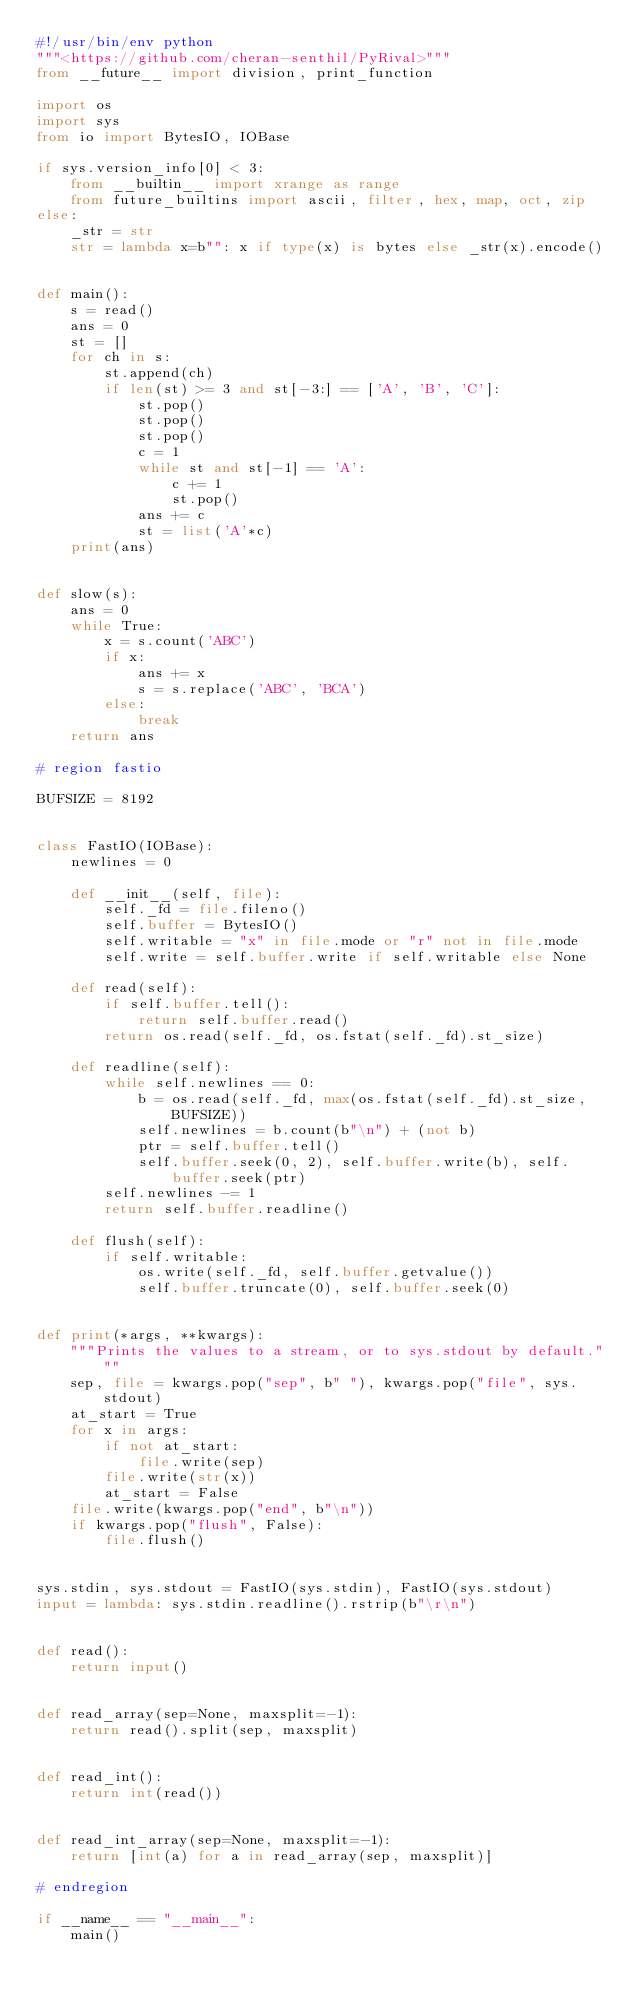Convert code to text. <code><loc_0><loc_0><loc_500><loc_500><_Python_>#!/usr/bin/env python
"""<https://github.com/cheran-senthil/PyRival>"""
from __future__ import division, print_function

import os
import sys
from io import BytesIO, IOBase

if sys.version_info[0] < 3:
    from __builtin__ import xrange as range
    from future_builtins import ascii, filter, hex, map, oct, zip
else:
    _str = str
    str = lambda x=b"": x if type(x) is bytes else _str(x).encode()


def main():
    s = read()
    ans = 0
    st = []
    for ch in s:
        st.append(ch)
        if len(st) >= 3 and st[-3:] == ['A', 'B', 'C']:
            st.pop()
            st.pop()
            st.pop()
            c = 1
            while st and st[-1] == 'A':
                c += 1
                st.pop()
            ans += c
            st = list('A'*c)
    print(ans)


def slow(s):
    ans = 0
    while True:
        x = s.count('ABC')
        if x:
            ans += x
            s = s.replace('ABC', 'BCA')
        else:
            break
    return ans

# region fastio

BUFSIZE = 8192


class FastIO(IOBase):
    newlines = 0

    def __init__(self, file):
        self._fd = file.fileno()
        self.buffer = BytesIO()
        self.writable = "x" in file.mode or "r" not in file.mode
        self.write = self.buffer.write if self.writable else None

    def read(self):
        if self.buffer.tell():
            return self.buffer.read()
        return os.read(self._fd, os.fstat(self._fd).st_size)

    def readline(self):
        while self.newlines == 0:
            b = os.read(self._fd, max(os.fstat(self._fd).st_size, BUFSIZE))
            self.newlines = b.count(b"\n") + (not b)
            ptr = self.buffer.tell()
            self.buffer.seek(0, 2), self.buffer.write(b), self.buffer.seek(ptr)
        self.newlines -= 1
        return self.buffer.readline()

    def flush(self):
        if self.writable:
            os.write(self._fd, self.buffer.getvalue())
            self.buffer.truncate(0), self.buffer.seek(0)


def print(*args, **kwargs):
    """Prints the values to a stream, or to sys.stdout by default."""
    sep, file = kwargs.pop("sep", b" "), kwargs.pop("file", sys.stdout)
    at_start = True
    for x in args:
        if not at_start:
            file.write(sep)
        file.write(str(x))
        at_start = False
    file.write(kwargs.pop("end", b"\n"))
    if kwargs.pop("flush", False):
        file.flush()


sys.stdin, sys.stdout = FastIO(sys.stdin), FastIO(sys.stdout)
input = lambda: sys.stdin.readline().rstrip(b"\r\n")


def read():
    return input()


def read_array(sep=None, maxsplit=-1):
    return read().split(sep, maxsplit)


def read_int():
    return int(read())


def read_int_array(sep=None, maxsplit=-1):
    return [int(a) for a in read_array(sep, maxsplit)]

# endregion

if __name__ == "__main__":
    main()
</code> 